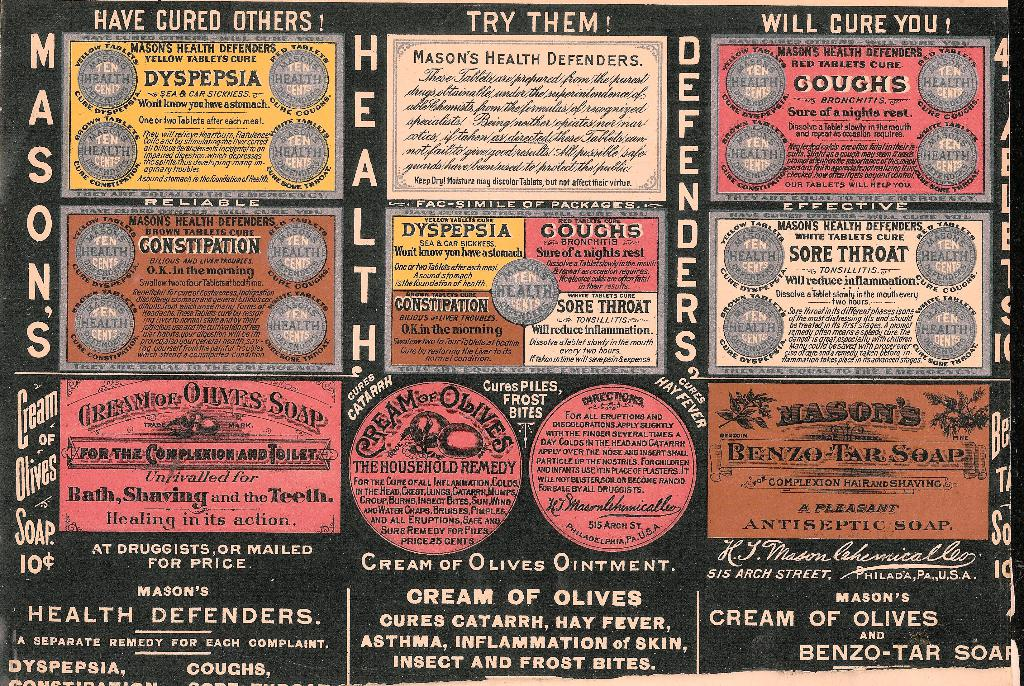What time period does the advertising style of this image suggest? The typeface, language, and design of the advertisement suggest it originated from the late 19th to early 20th century, a time when medicinal products were heavily promoted with bold claims and endorsements. Can you give more details about the health issues mentioned in the advertisement? Certainly, the advertisement claims to offer cures for various health issues such as dyspepsia (indigestion), coughs, sore throat, constipation, catarrh (inflammation of mucous membranes), hay fever, skin inflammation, asthma, and insect and frost bites. 